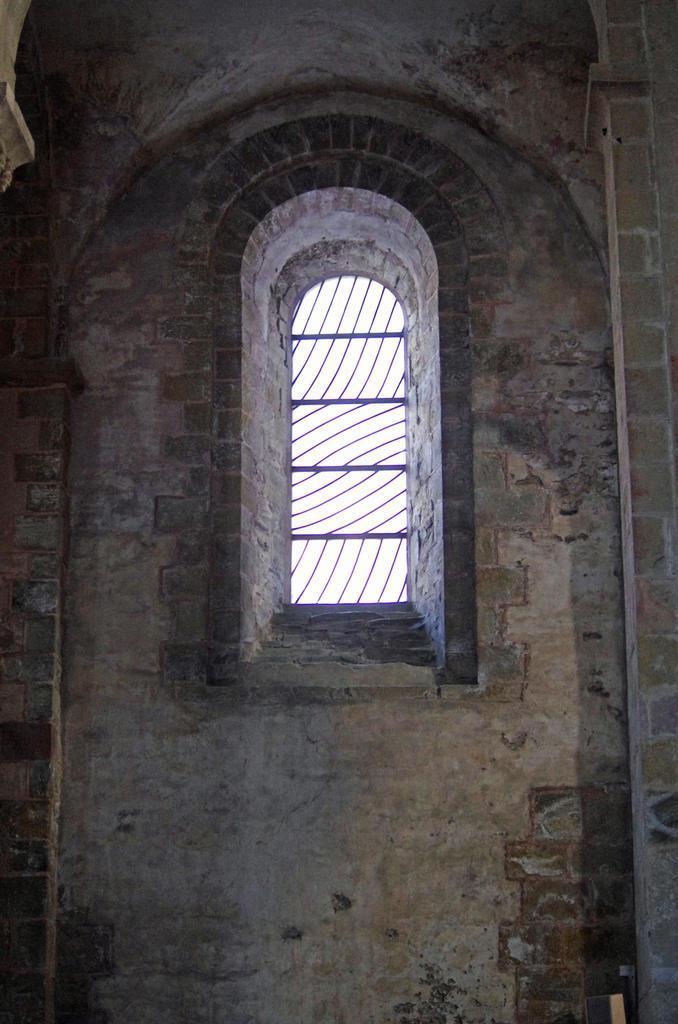In one or two sentences, can you explain what this image depicts? In this image there is a wall and we can see a window. 